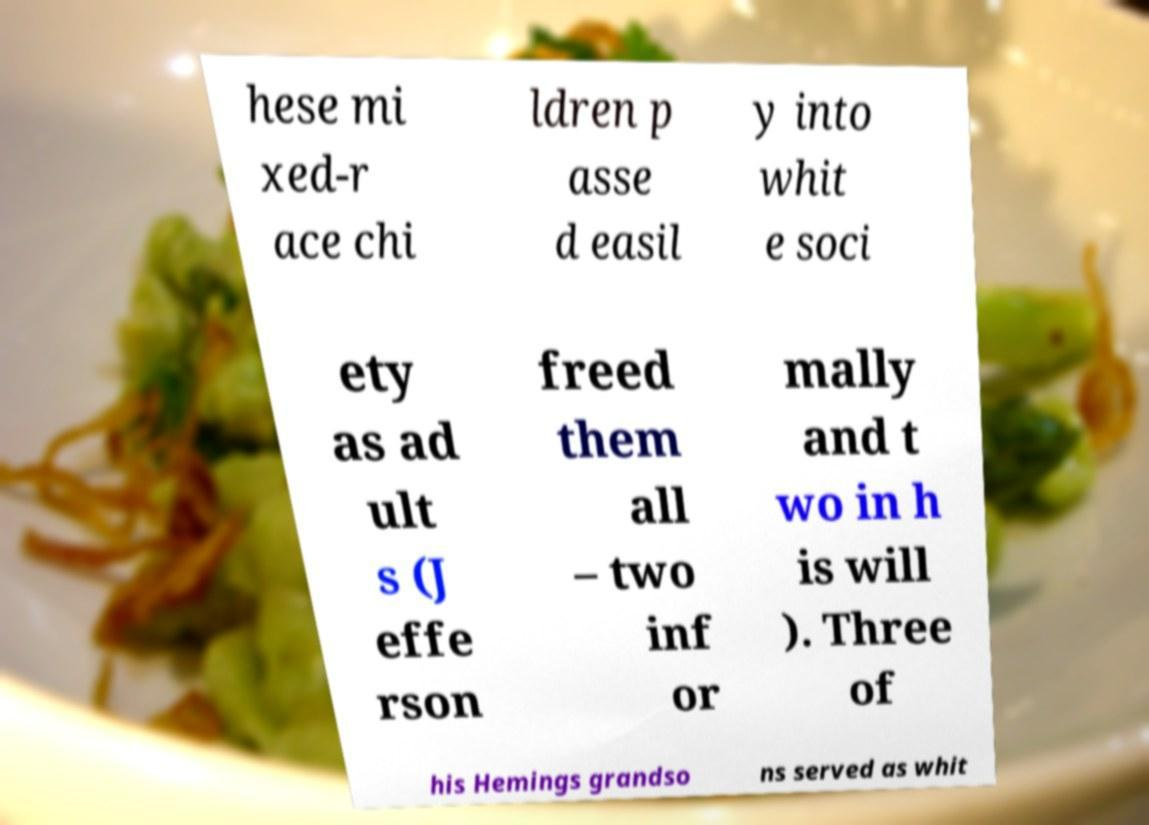There's text embedded in this image that I need extracted. Can you transcribe it verbatim? hese mi xed-r ace chi ldren p asse d easil y into whit e soci ety as ad ult s (J effe rson freed them all – two inf or mally and t wo in h is will ). Three of his Hemings grandso ns served as whit 